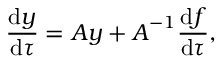<formula> <loc_0><loc_0><loc_500><loc_500>\frac { d y } { d \tau } = A y + A ^ { - 1 } \frac { d f } { d \tau } ,</formula> 